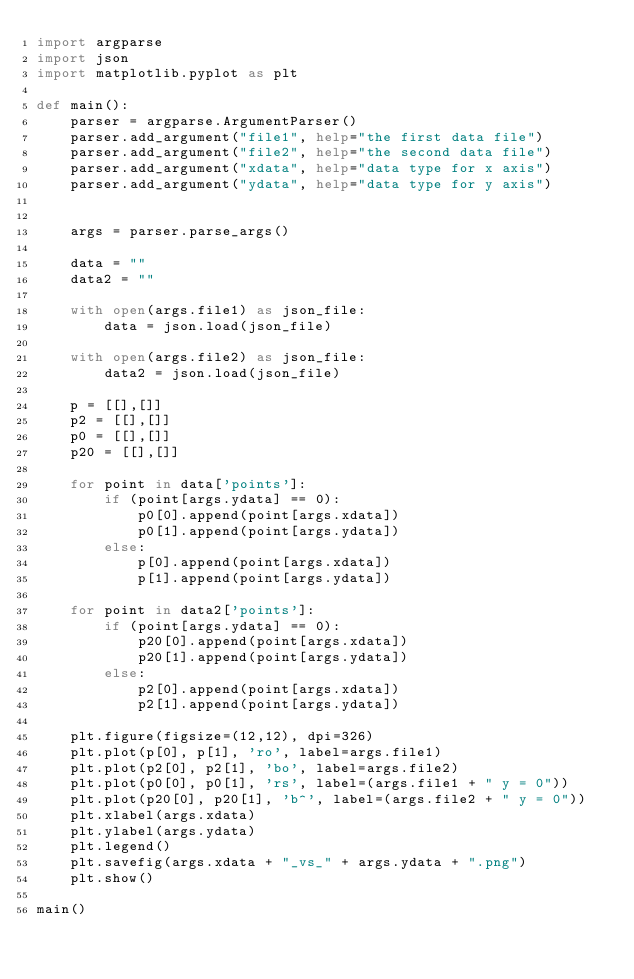Convert code to text. <code><loc_0><loc_0><loc_500><loc_500><_Python_>import argparse
import json
import matplotlib.pyplot as plt

def main():
    parser = argparse.ArgumentParser()
    parser.add_argument("file1", help="the first data file")
    parser.add_argument("file2", help="the second data file")
    parser.add_argument("xdata", help="data type for x axis")
    parser.add_argument("ydata", help="data type for y axis")


    args = parser.parse_args()

    data = ""
    data2 = ""

    with open(args.file1) as json_file:
        data = json.load(json_file)

    with open(args.file2) as json_file:
        data2 = json.load(json_file)

    p = [[],[]]
    p2 = [[],[]]
    p0 = [[],[]]
    p20 = [[],[]]

    for point in data['points']:
        if (point[args.ydata] == 0):
            p0[0].append(point[args.xdata])
            p0[1].append(point[args.ydata])
        else:
            p[0].append(point[args.xdata])
            p[1].append(point[args.ydata])

    for point in data2['points']:
        if (point[args.ydata] == 0):
            p20[0].append(point[args.xdata])
            p20[1].append(point[args.ydata])
        else:
            p2[0].append(point[args.xdata])
            p2[1].append(point[args.ydata])

    plt.figure(figsize=(12,12), dpi=326)
    plt.plot(p[0], p[1], 'ro', label=args.file1)
    plt.plot(p2[0], p2[1], 'bo', label=args.file2)
    plt.plot(p0[0], p0[1], 'rs', label=(args.file1 + " y = 0"))
    plt.plot(p20[0], p20[1], 'b^', label=(args.file2 + " y = 0"))
    plt.xlabel(args.xdata)
    plt.ylabel(args.ydata)
    plt.legend()
    plt.savefig(args.xdata + "_vs_" + args.ydata + ".png")
    plt.show()

main()
</code> 